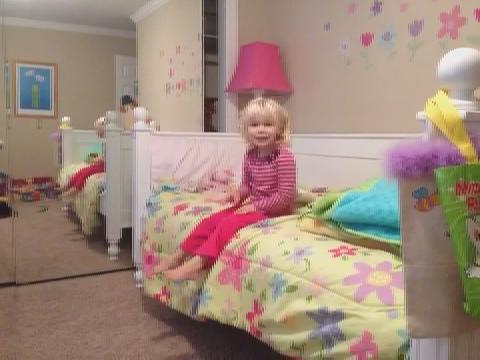What type of finish or item covers the back wall? flowers 